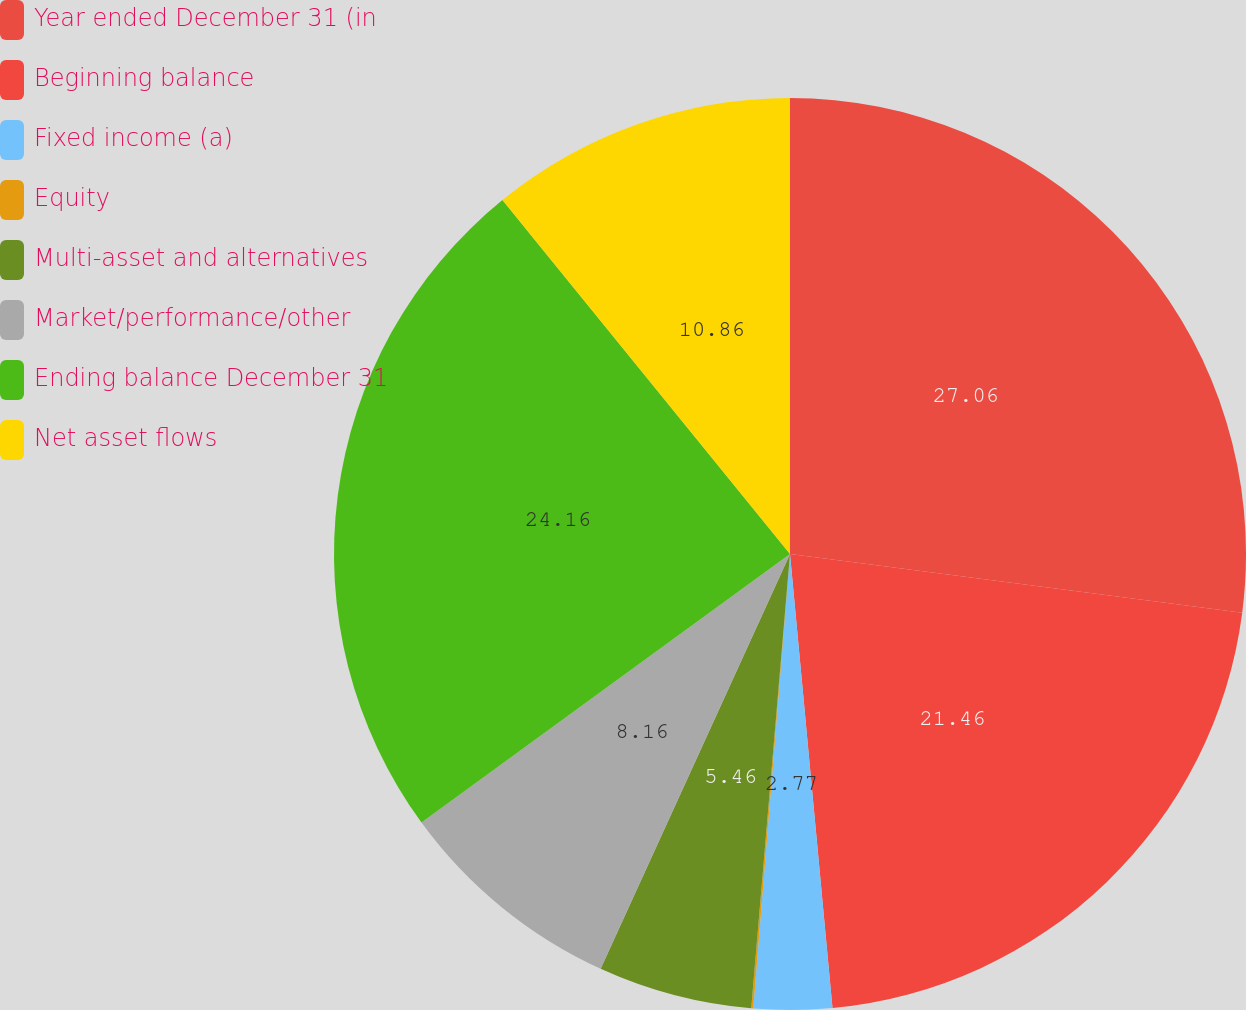Convert chart to OTSL. <chart><loc_0><loc_0><loc_500><loc_500><pie_chart><fcel>Year ended December 31 (in<fcel>Beginning balance<fcel>Fixed income (a)<fcel>Equity<fcel>Multi-asset and alternatives<fcel>Market/performance/other<fcel>Ending balance December 31<fcel>Net asset flows<nl><fcel>27.05%<fcel>21.46%<fcel>2.77%<fcel>0.07%<fcel>5.46%<fcel>8.16%<fcel>24.16%<fcel>10.86%<nl></chart> 